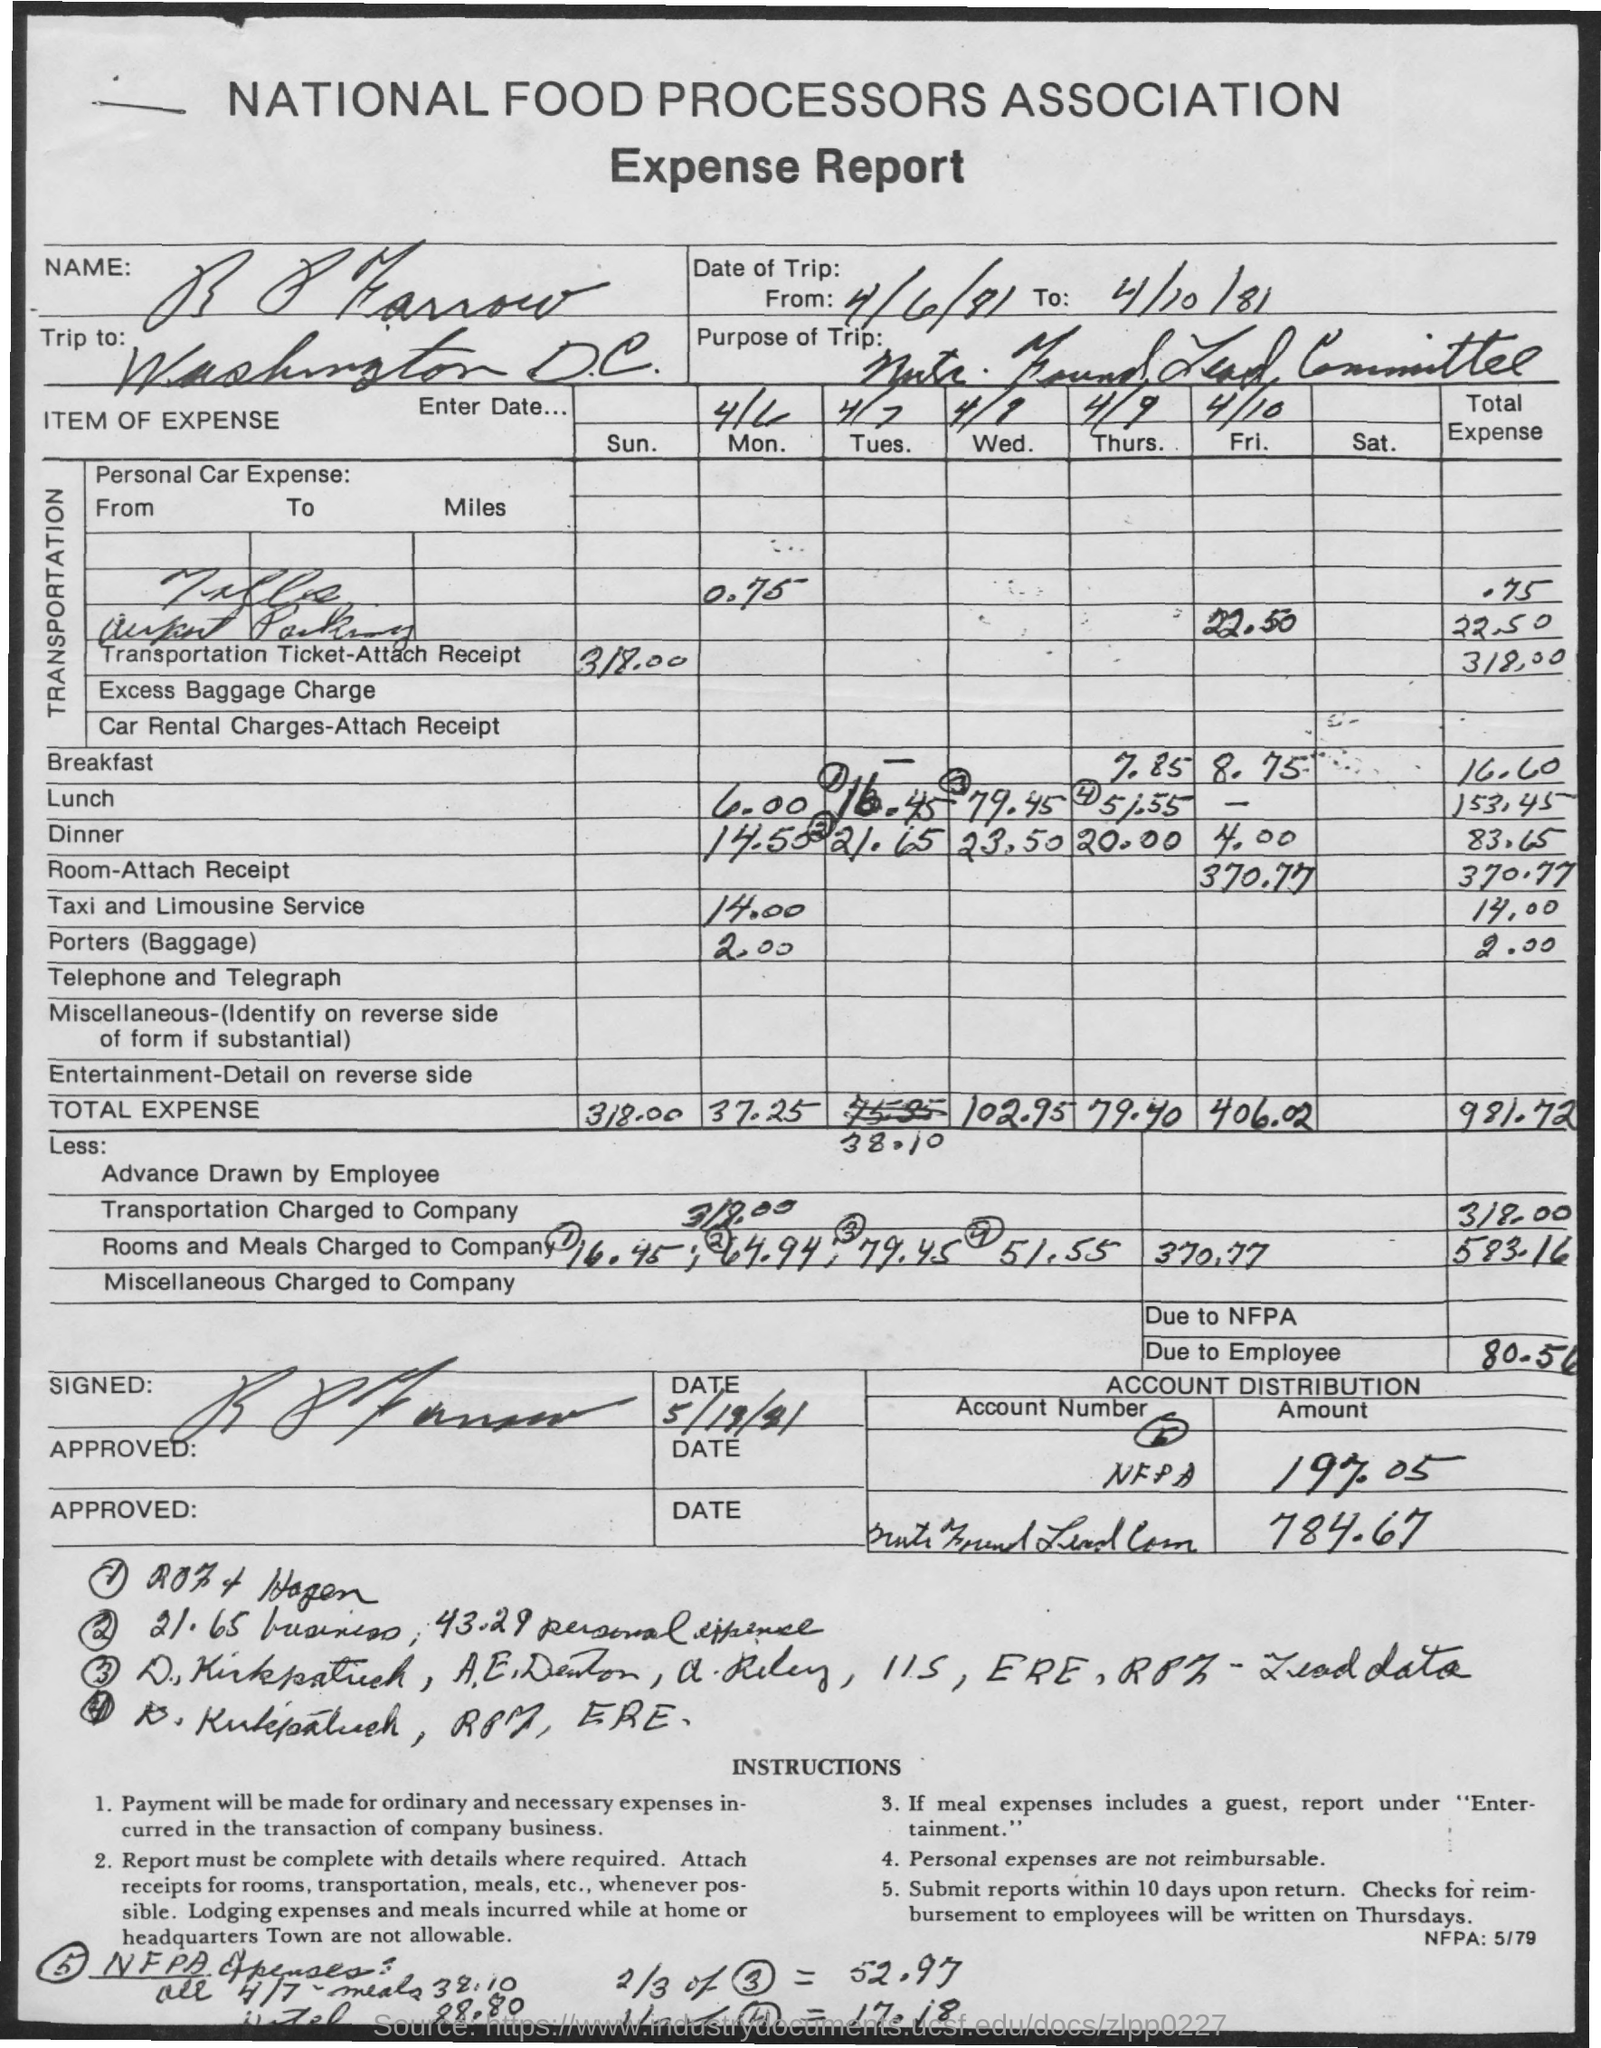Are there any instructions or policies noted on the expense report that the employee had to follow? The expense report includes instructions indicating that ordinary and necessary expenses will be reimbursed and reporting should be detailed. Receipts for transportation, meals, and lodging are required. The policy also notes that personal expenses are not reimbursable and reimbursement checks are issued on Thursdays. 